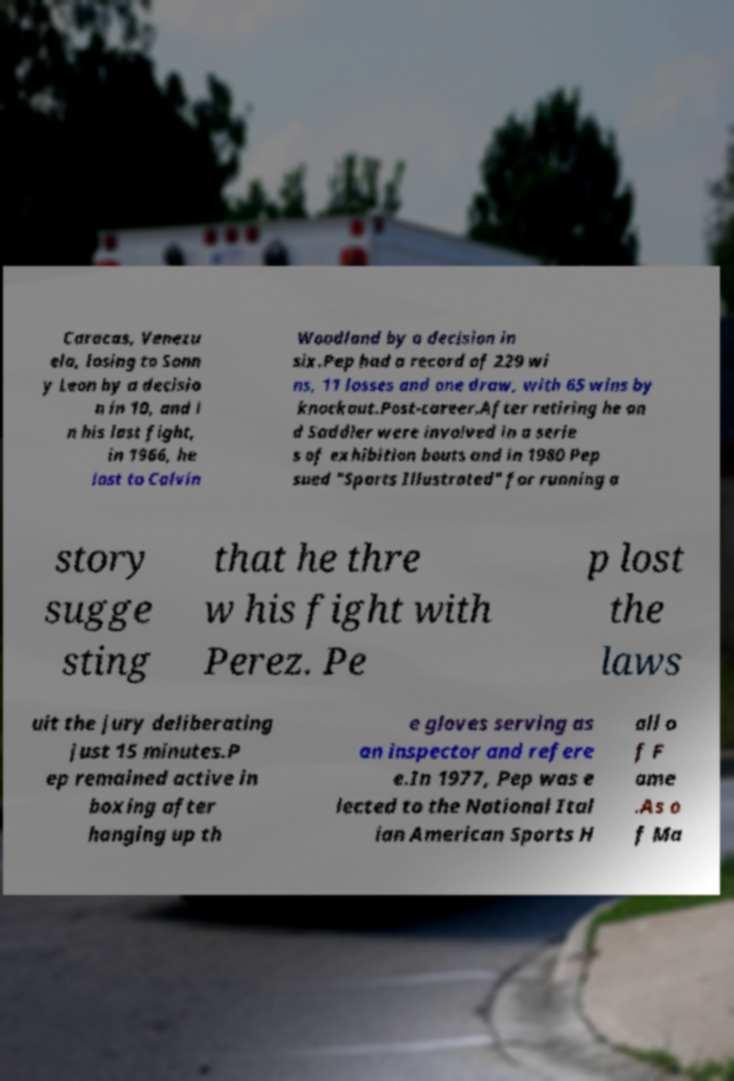Could you extract and type out the text from this image? Caracas, Venezu ela, losing to Sonn y Leon by a decisio n in 10, and i n his last fight, in 1966, he lost to Calvin Woodland by a decision in six.Pep had a record of 229 wi ns, 11 losses and one draw, with 65 wins by knockout.Post-career.After retiring he an d Saddler were involved in a serie s of exhibition bouts and in 1980 Pep sued "Sports Illustrated" for running a story sugge sting that he thre w his fight with Perez. Pe p lost the laws uit the jury deliberating just 15 minutes.P ep remained active in boxing after hanging up th e gloves serving as an inspector and refere e.In 1977, Pep was e lected to the National Ital ian American Sports H all o f F ame .As o f Ma 